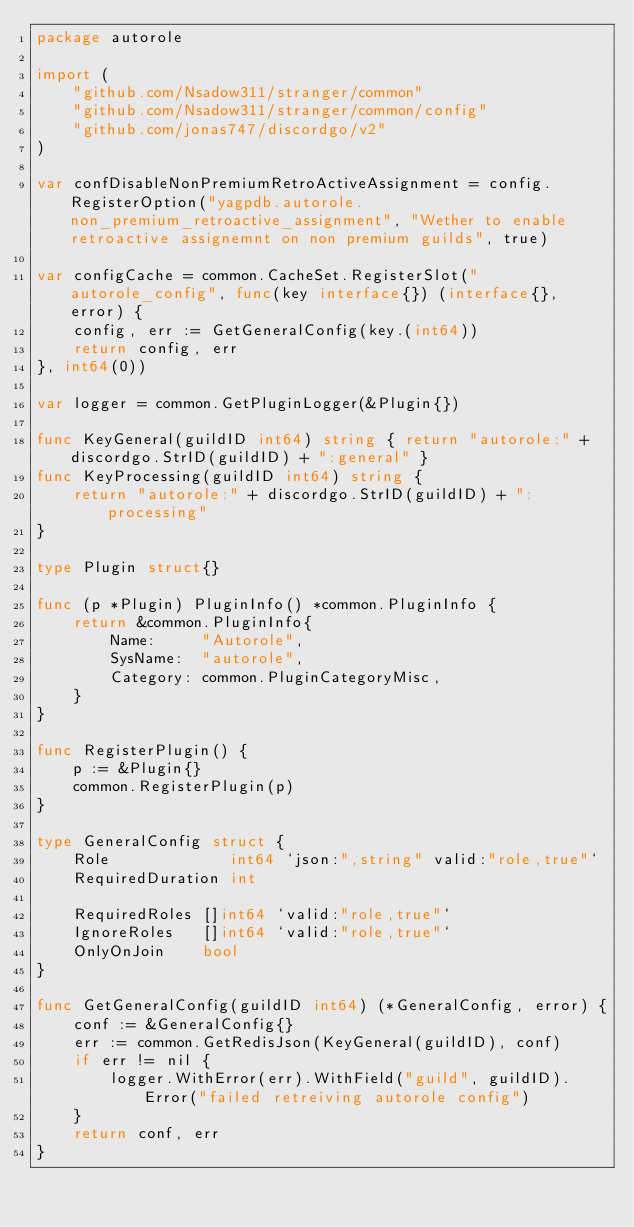Convert code to text. <code><loc_0><loc_0><loc_500><loc_500><_Go_>package autorole

import (
	"github.com/Nsadow311/stranger/common"
	"github.com/Nsadow311/stranger/common/config"
	"github.com/jonas747/discordgo/v2"
)

var confDisableNonPremiumRetroActiveAssignment = config.RegisterOption("yagpdb.autorole.non_premium_retroactive_assignment", "Wether to enable retroactive assignemnt on non premium guilds", true)

var configCache = common.CacheSet.RegisterSlot("autorole_config", func(key interface{}) (interface{}, error) {
	config, err := GetGeneralConfig(key.(int64))
	return config, err
}, int64(0))

var logger = common.GetPluginLogger(&Plugin{})

func KeyGeneral(guildID int64) string { return "autorole:" + discordgo.StrID(guildID) + ":general" }
func KeyProcessing(guildID int64) string {
	return "autorole:" + discordgo.StrID(guildID) + ":processing"
}

type Plugin struct{}

func (p *Plugin) PluginInfo() *common.PluginInfo {
	return &common.PluginInfo{
		Name:     "Autorole",
		SysName:  "autorole",
		Category: common.PluginCategoryMisc,
	}
}

func RegisterPlugin() {
	p := &Plugin{}
	common.RegisterPlugin(p)
}

type GeneralConfig struct {
	Role             int64 `json:",string" valid:"role,true"`
	RequiredDuration int

	RequiredRoles []int64 `valid:"role,true"`
	IgnoreRoles   []int64 `valid:"role,true"`
	OnlyOnJoin    bool
}

func GetGeneralConfig(guildID int64) (*GeneralConfig, error) {
	conf := &GeneralConfig{}
	err := common.GetRedisJson(KeyGeneral(guildID), conf)
	if err != nil {
		logger.WithError(err).WithField("guild", guildID).Error("failed retreiving autorole config")
	}
	return conf, err
}
</code> 